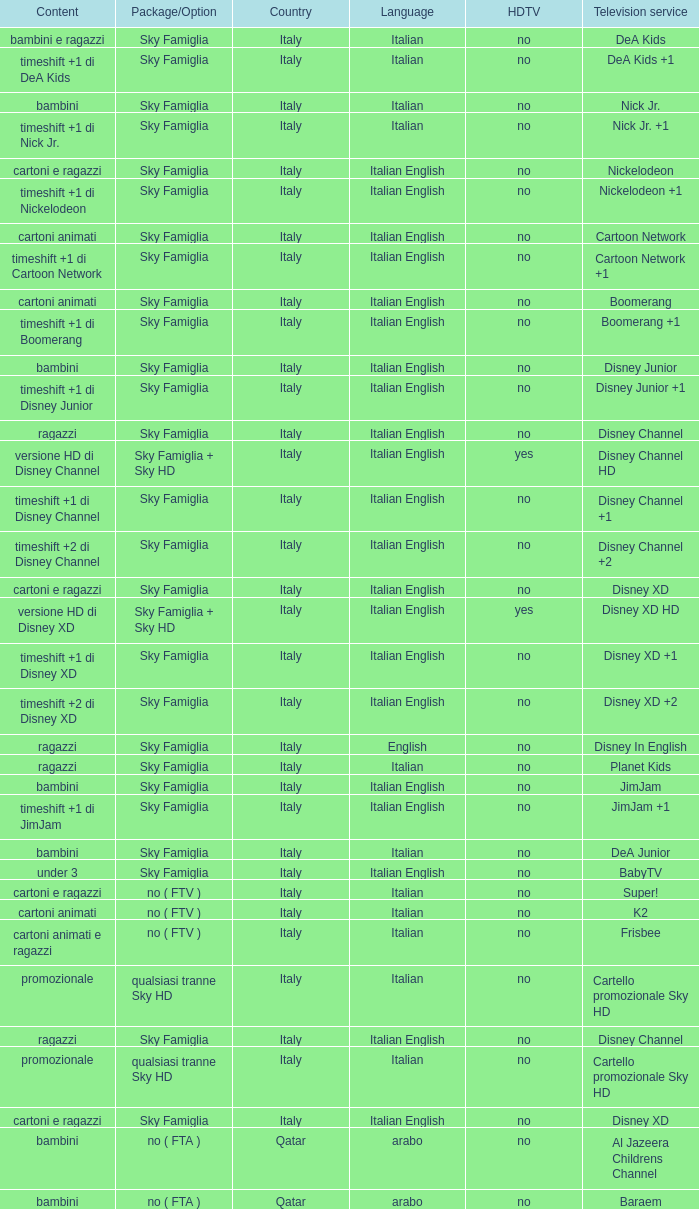What shows as Content for the Television service of nickelodeon +1? Timeshift +1 di nickelodeon. 